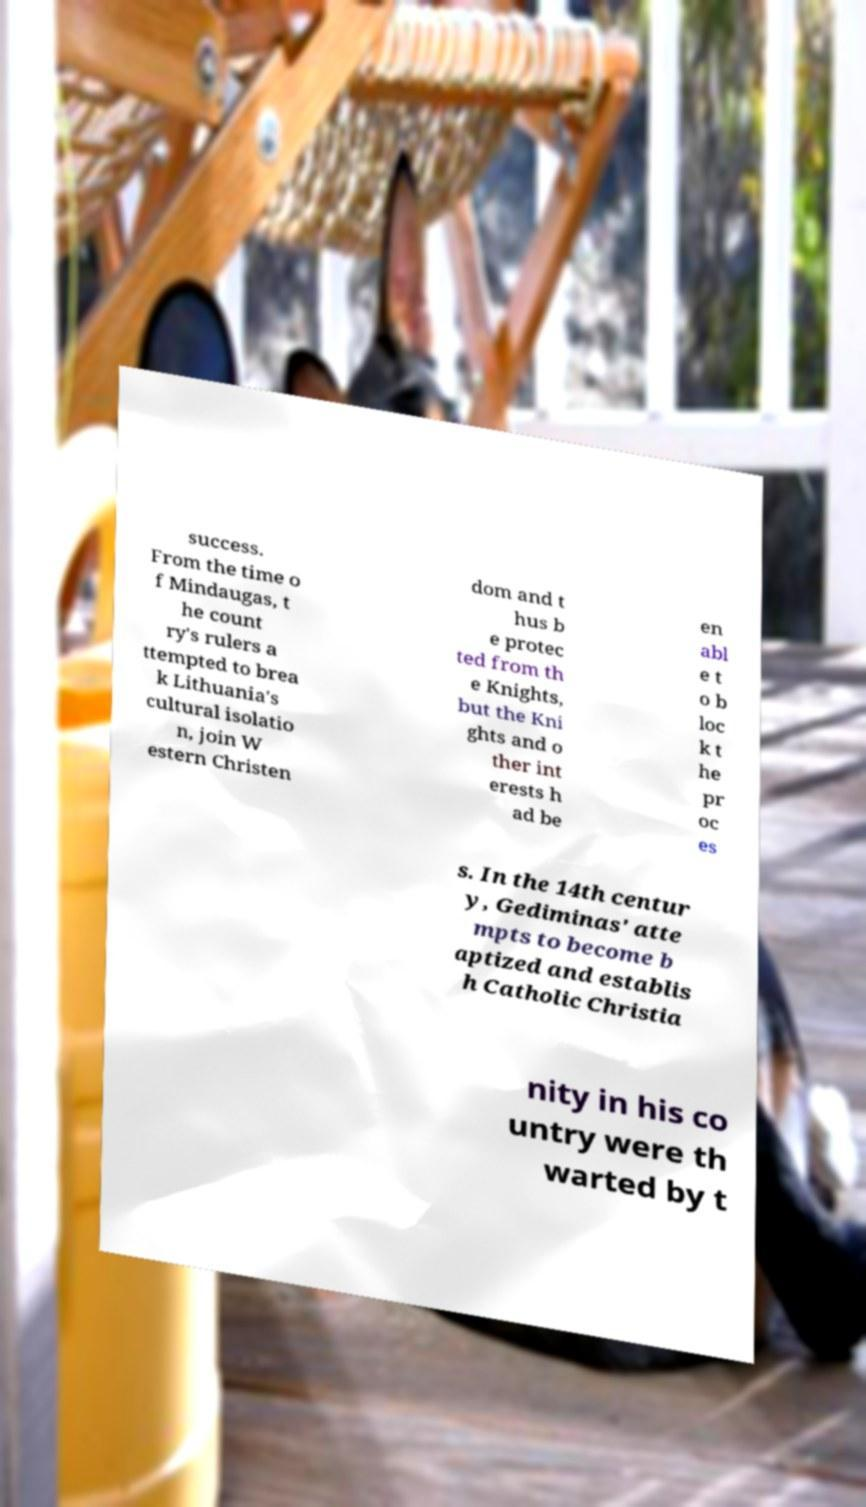For documentation purposes, I need the text within this image transcribed. Could you provide that? success. From the time o f Mindaugas, t he count ry's rulers a ttempted to brea k Lithuania's cultural isolatio n, join W estern Christen dom and t hus b e protec ted from th e Knights, but the Kni ghts and o ther int erests h ad be en abl e t o b loc k t he pr oc es s. In the 14th centur y, Gediminas' atte mpts to become b aptized and establis h Catholic Christia nity in his co untry were th warted by t 